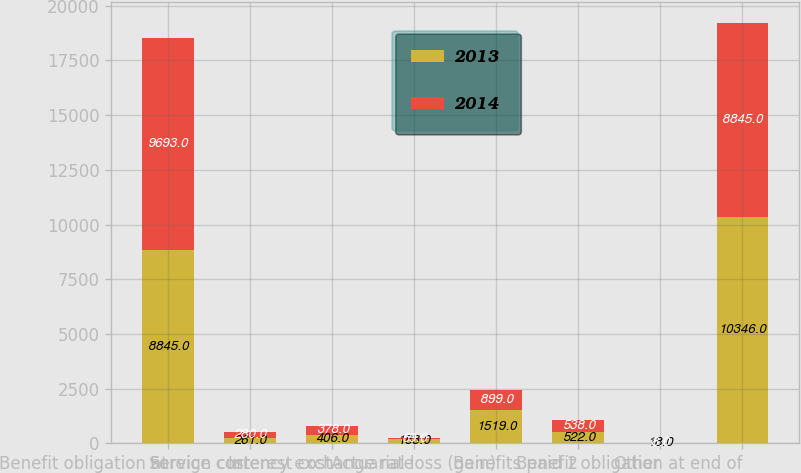Convert chart. <chart><loc_0><loc_0><loc_500><loc_500><stacked_bar_chart><ecel><fcel>Benefit obligation at<fcel>Service cost<fcel>Interest cost<fcel>Foreign currency exchange rate<fcel>Actuarial loss (gain)<fcel>Benefits paid 2<fcel>Other<fcel>Benefit obligation at end of<nl><fcel>2013<fcel>8845<fcel>261<fcel>406<fcel>183<fcel>1519<fcel>522<fcel>18<fcel>10346<nl><fcel>2014<fcel>9693<fcel>280<fcel>378<fcel>69<fcel>899<fcel>538<fcel>8<fcel>8845<nl></chart> 